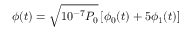<formula> <loc_0><loc_0><loc_500><loc_500>\phi ( t ) = \sqrt { 1 0 ^ { - 7 } P _ { 0 } } \, [ \phi _ { 0 } ( t ) + 5 \phi _ { 1 } ( t ) ]</formula> 